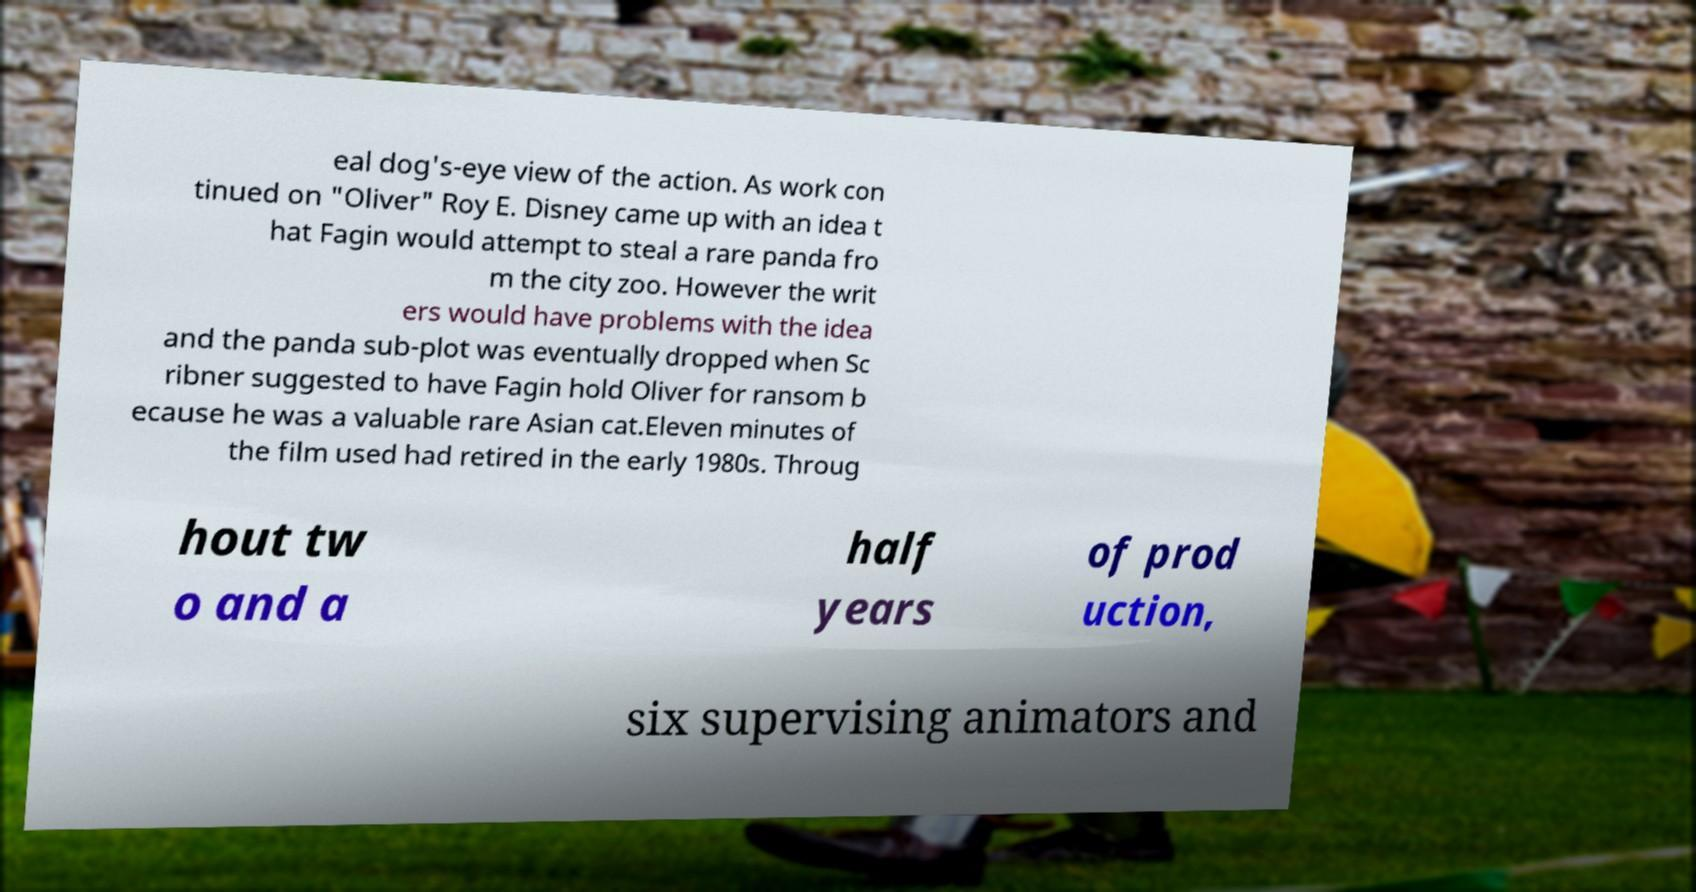Can you accurately transcribe the text from the provided image for me? eal dog's-eye view of the action. As work con tinued on "Oliver" Roy E. Disney came up with an idea t hat Fagin would attempt to steal a rare panda fro m the city zoo. However the writ ers would have problems with the idea and the panda sub-plot was eventually dropped when Sc ribner suggested to have Fagin hold Oliver for ransom b ecause he was a valuable rare Asian cat.Eleven minutes of the film used had retired in the early 1980s. Throug hout tw o and a half years of prod uction, six supervising animators and 